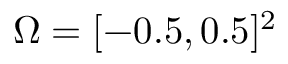Convert formula to latex. <formula><loc_0><loc_0><loc_500><loc_500>\Omega = [ - 0 . 5 , 0 . 5 ] ^ { 2 }</formula> 